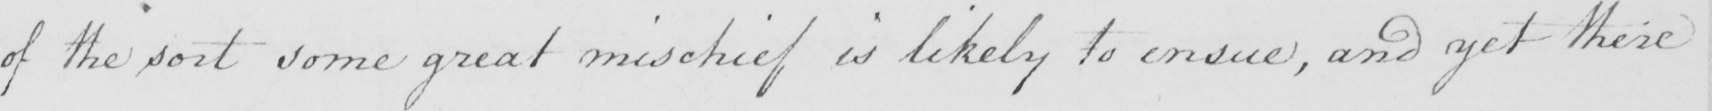What text is written in this handwritten line? of the sort some great mischief is likely to ensue , and yet there 